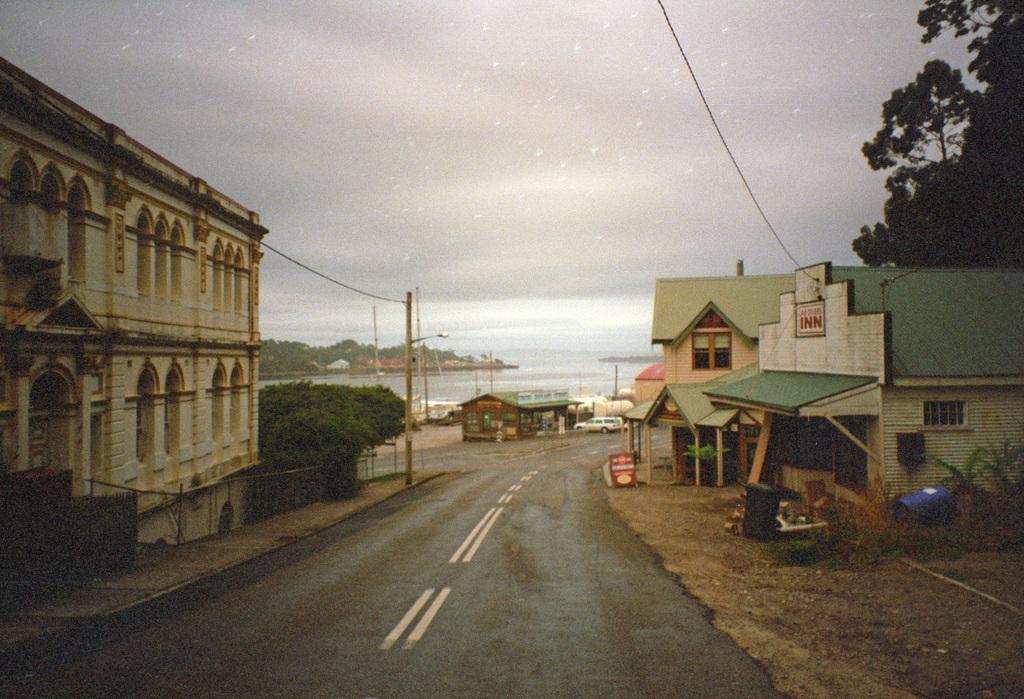In one or two sentences, can you explain what this image depicts? In this picture we can see houses, electric poles with cables and a road. On the right side of the houses there are trees and behind the houses there is a vehicle, water and the sky. 